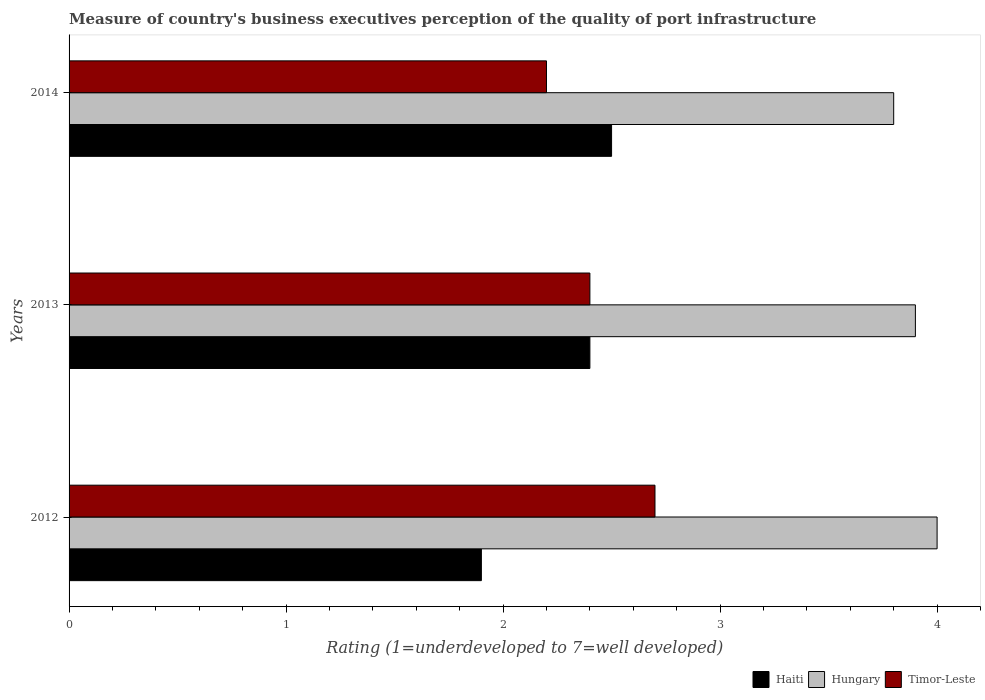Are the number of bars per tick equal to the number of legend labels?
Ensure brevity in your answer.  Yes. Are the number of bars on each tick of the Y-axis equal?
Offer a terse response. Yes. How many bars are there on the 2nd tick from the bottom?
Your answer should be compact. 3. In how many cases, is the number of bars for a given year not equal to the number of legend labels?
Provide a succinct answer. 0. What is the ratings of the quality of port infrastructure in Haiti in 2012?
Offer a terse response. 1.9. In which year was the ratings of the quality of port infrastructure in Haiti maximum?
Make the answer very short. 2014. What is the difference between the ratings of the quality of port infrastructure in Hungary in 2012 and that in 2013?
Your answer should be very brief. 0.1. What is the difference between the ratings of the quality of port infrastructure in Timor-Leste in 2014 and the ratings of the quality of port infrastructure in Haiti in 2013?
Your answer should be very brief. -0.2. What is the average ratings of the quality of port infrastructure in Timor-Leste per year?
Offer a very short reply. 2.43. In the year 2014, what is the difference between the ratings of the quality of port infrastructure in Timor-Leste and ratings of the quality of port infrastructure in Hungary?
Give a very brief answer. -1.6. What is the ratio of the ratings of the quality of port infrastructure in Timor-Leste in 2012 to that in 2013?
Provide a short and direct response. 1.13. What is the difference between the highest and the second highest ratings of the quality of port infrastructure in Hungary?
Offer a very short reply. 0.1. What is the difference between the highest and the lowest ratings of the quality of port infrastructure in Haiti?
Give a very brief answer. 0.6. In how many years, is the ratings of the quality of port infrastructure in Timor-Leste greater than the average ratings of the quality of port infrastructure in Timor-Leste taken over all years?
Give a very brief answer. 1. Is the sum of the ratings of the quality of port infrastructure in Timor-Leste in 2012 and 2014 greater than the maximum ratings of the quality of port infrastructure in Haiti across all years?
Offer a very short reply. Yes. What does the 1st bar from the top in 2012 represents?
Keep it short and to the point. Timor-Leste. What does the 1st bar from the bottom in 2013 represents?
Give a very brief answer. Haiti. Is it the case that in every year, the sum of the ratings of the quality of port infrastructure in Haiti and ratings of the quality of port infrastructure in Timor-Leste is greater than the ratings of the quality of port infrastructure in Hungary?
Provide a succinct answer. Yes. How many bars are there?
Ensure brevity in your answer.  9. Are the values on the major ticks of X-axis written in scientific E-notation?
Your response must be concise. No. Where does the legend appear in the graph?
Provide a short and direct response. Bottom right. How many legend labels are there?
Your response must be concise. 3. How are the legend labels stacked?
Make the answer very short. Horizontal. What is the title of the graph?
Give a very brief answer. Measure of country's business executives perception of the quality of port infrastructure. Does "Cuba" appear as one of the legend labels in the graph?
Provide a short and direct response. No. What is the label or title of the X-axis?
Provide a succinct answer. Rating (1=underdeveloped to 7=well developed). What is the Rating (1=underdeveloped to 7=well developed) of Haiti in 2012?
Keep it short and to the point. 1.9. What is the Rating (1=underdeveloped to 7=well developed) of Hungary in 2012?
Your answer should be very brief. 4. What is the Rating (1=underdeveloped to 7=well developed) of Haiti in 2013?
Make the answer very short. 2.4. What is the Rating (1=underdeveloped to 7=well developed) of Timor-Leste in 2013?
Make the answer very short. 2.4. What is the Rating (1=underdeveloped to 7=well developed) of Hungary in 2014?
Provide a short and direct response. 3.8. Across all years, what is the maximum Rating (1=underdeveloped to 7=well developed) in Haiti?
Offer a very short reply. 2.5. Across all years, what is the minimum Rating (1=underdeveloped to 7=well developed) of Haiti?
Offer a very short reply. 1.9. Across all years, what is the minimum Rating (1=underdeveloped to 7=well developed) in Hungary?
Give a very brief answer. 3.8. What is the difference between the Rating (1=underdeveloped to 7=well developed) of Haiti in 2012 and that in 2013?
Offer a very short reply. -0.5. What is the difference between the Rating (1=underdeveloped to 7=well developed) of Hungary in 2012 and that in 2013?
Your answer should be compact. 0.1. What is the difference between the Rating (1=underdeveloped to 7=well developed) in Timor-Leste in 2012 and that in 2013?
Your answer should be compact. 0.3. What is the difference between the Rating (1=underdeveloped to 7=well developed) in Hungary in 2012 and that in 2014?
Make the answer very short. 0.2. What is the difference between the Rating (1=underdeveloped to 7=well developed) of Timor-Leste in 2012 and that in 2014?
Provide a short and direct response. 0.5. What is the difference between the Rating (1=underdeveloped to 7=well developed) in Hungary in 2013 and that in 2014?
Offer a very short reply. 0.1. What is the difference between the Rating (1=underdeveloped to 7=well developed) of Haiti in 2012 and the Rating (1=underdeveloped to 7=well developed) of Timor-Leste in 2013?
Offer a terse response. -0.5. What is the difference between the Rating (1=underdeveloped to 7=well developed) of Hungary in 2012 and the Rating (1=underdeveloped to 7=well developed) of Timor-Leste in 2013?
Make the answer very short. 1.6. What is the difference between the Rating (1=underdeveloped to 7=well developed) of Haiti in 2012 and the Rating (1=underdeveloped to 7=well developed) of Timor-Leste in 2014?
Your answer should be compact. -0.3. What is the difference between the Rating (1=underdeveloped to 7=well developed) in Haiti in 2013 and the Rating (1=underdeveloped to 7=well developed) in Hungary in 2014?
Ensure brevity in your answer.  -1.4. What is the difference between the Rating (1=underdeveloped to 7=well developed) in Hungary in 2013 and the Rating (1=underdeveloped to 7=well developed) in Timor-Leste in 2014?
Offer a terse response. 1.7. What is the average Rating (1=underdeveloped to 7=well developed) of Haiti per year?
Give a very brief answer. 2.27. What is the average Rating (1=underdeveloped to 7=well developed) of Hungary per year?
Offer a very short reply. 3.9. What is the average Rating (1=underdeveloped to 7=well developed) in Timor-Leste per year?
Offer a terse response. 2.43. In the year 2012, what is the difference between the Rating (1=underdeveloped to 7=well developed) of Haiti and Rating (1=underdeveloped to 7=well developed) of Timor-Leste?
Ensure brevity in your answer.  -0.8. In the year 2013, what is the difference between the Rating (1=underdeveloped to 7=well developed) in Haiti and Rating (1=underdeveloped to 7=well developed) in Hungary?
Provide a succinct answer. -1.5. In the year 2013, what is the difference between the Rating (1=underdeveloped to 7=well developed) of Haiti and Rating (1=underdeveloped to 7=well developed) of Timor-Leste?
Give a very brief answer. 0. In the year 2014, what is the difference between the Rating (1=underdeveloped to 7=well developed) of Haiti and Rating (1=underdeveloped to 7=well developed) of Hungary?
Provide a short and direct response. -1.3. In the year 2014, what is the difference between the Rating (1=underdeveloped to 7=well developed) of Haiti and Rating (1=underdeveloped to 7=well developed) of Timor-Leste?
Provide a succinct answer. 0.3. In the year 2014, what is the difference between the Rating (1=underdeveloped to 7=well developed) of Hungary and Rating (1=underdeveloped to 7=well developed) of Timor-Leste?
Provide a short and direct response. 1.6. What is the ratio of the Rating (1=underdeveloped to 7=well developed) in Haiti in 2012 to that in 2013?
Your response must be concise. 0.79. What is the ratio of the Rating (1=underdeveloped to 7=well developed) in Hungary in 2012 to that in 2013?
Offer a very short reply. 1.03. What is the ratio of the Rating (1=underdeveloped to 7=well developed) of Haiti in 2012 to that in 2014?
Your answer should be compact. 0.76. What is the ratio of the Rating (1=underdeveloped to 7=well developed) of Hungary in 2012 to that in 2014?
Provide a succinct answer. 1.05. What is the ratio of the Rating (1=underdeveloped to 7=well developed) of Timor-Leste in 2012 to that in 2014?
Ensure brevity in your answer.  1.23. What is the ratio of the Rating (1=underdeveloped to 7=well developed) in Hungary in 2013 to that in 2014?
Your answer should be compact. 1.03. What is the ratio of the Rating (1=underdeveloped to 7=well developed) of Timor-Leste in 2013 to that in 2014?
Provide a short and direct response. 1.09. 